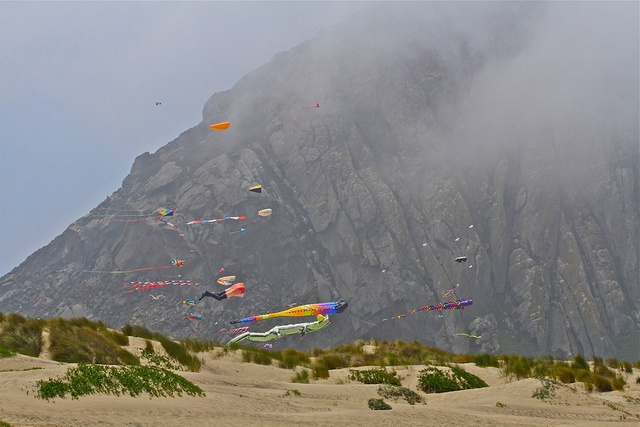Describe the objects in this image and their specific colors. I can see kite in lightgray, gray, darkgray, and brown tones, kite in lightgray, orange, gray, tan, and olive tones, kite in lightgray, olive, gray, darkgray, and ivory tones, kite in lightgray, gray, purple, brown, and navy tones, and kite in lightgray and gray tones in this image. 